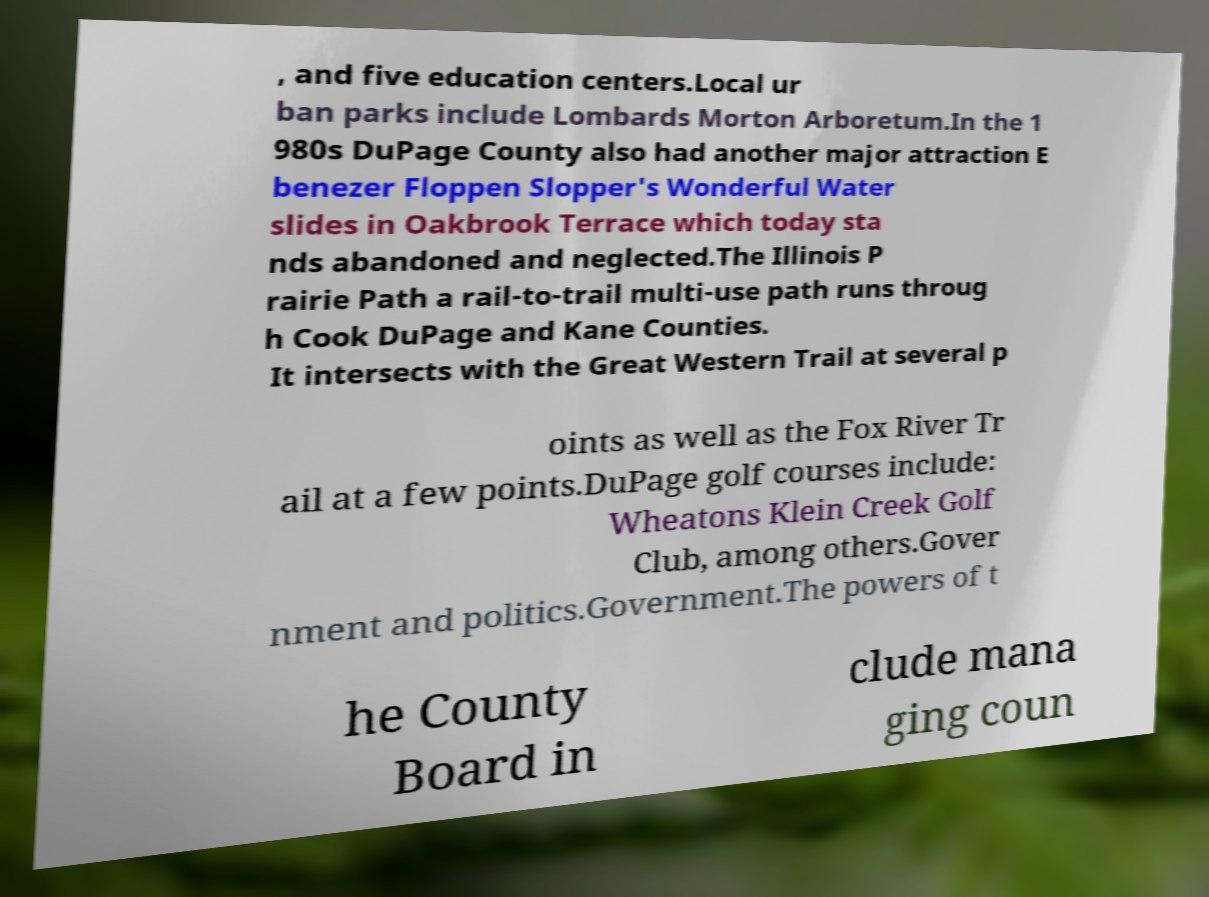For documentation purposes, I need the text within this image transcribed. Could you provide that? , and five education centers.Local ur ban parks include Lombards Morton Arboretum.In the 1 980s DuPage County also had another major attraction E benezer Floppen Slopper's Wonderful Water slides in Oakbrook Terrace which today sta nds abandoned and neglected.The Illinois P rairie Path a rail-to-trail multi-use path runs throug h Cook DuPage and Kane Counties. It intersects with the Great Western Trail at several p oints as well as the Fox River Tr ail at a few points.DuPage golf courses include: Wheatons Klein Creek Golf Club, among others.Gover nment and politics.Government.The powers of t he County Board in clude mana ging coun 